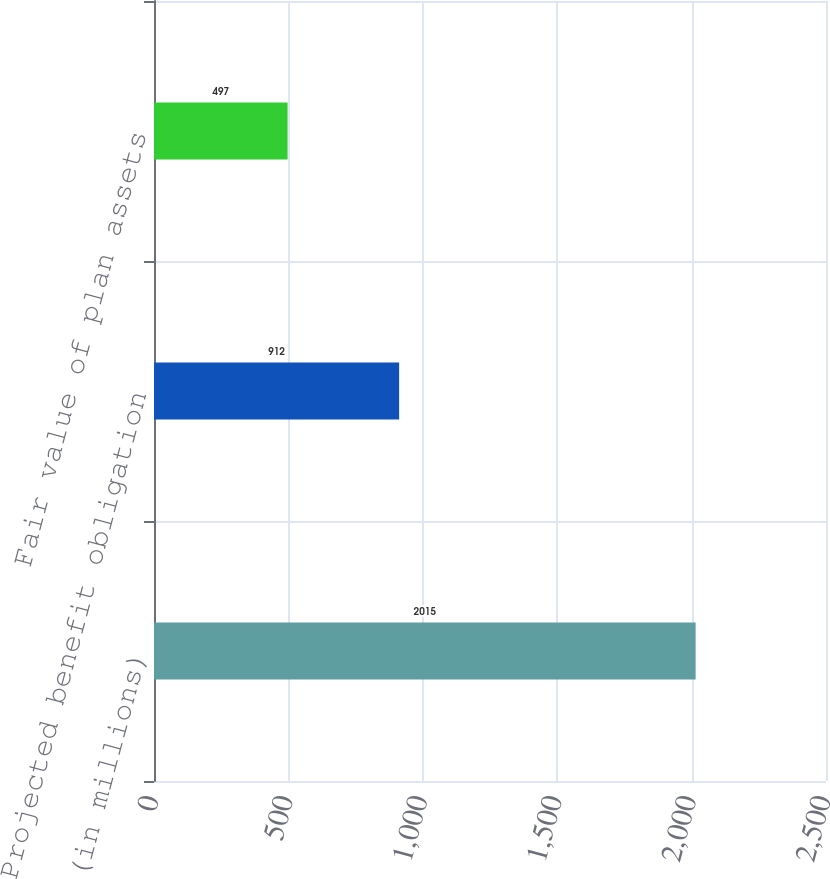Convert chart to OTSL. <chart><loc_0><loc_0><loc_500><loc_500><bar_chart><fcel>(in millions)<fcel>Projected benefit obligation<fcel>Fair value of plan assets<nl><fcel>2015<fcel>912<fcel>497<nl></chart> 